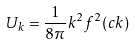<formula> <loc_0><loc_0><loc_500><loc_500>U _ { k } = \frac { 1 } { 8 \pi } k ^ { 2 } f ^ { 2 } ( c k )</formula> 